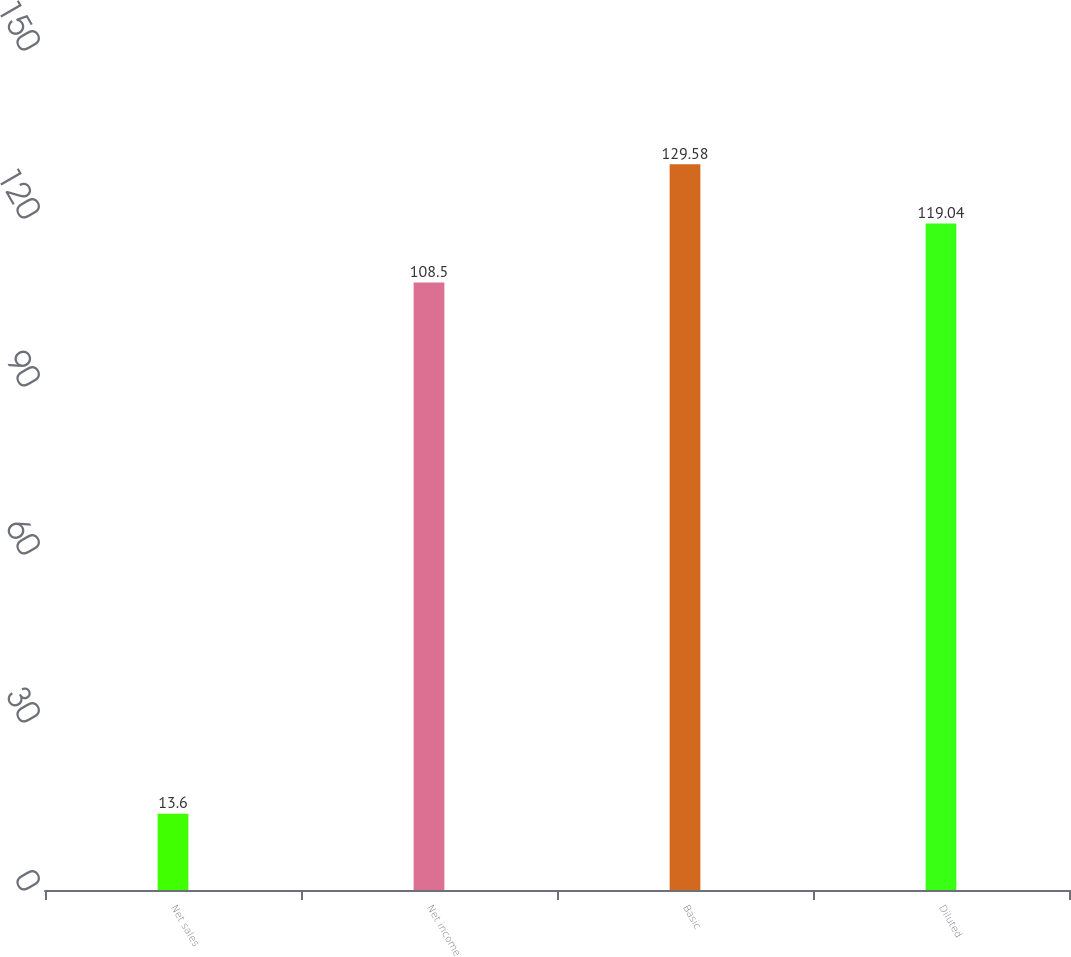<chart> <loc_0><loc_0><loc_500><loc_500><bar_chart><fcel>Net sales<fcel>Net income<fcel>Basic<fcel>Diluted<nl><fcel>13.6<fcel>108.5<fcel>129.58<fcel>119.04<nl></chart> 